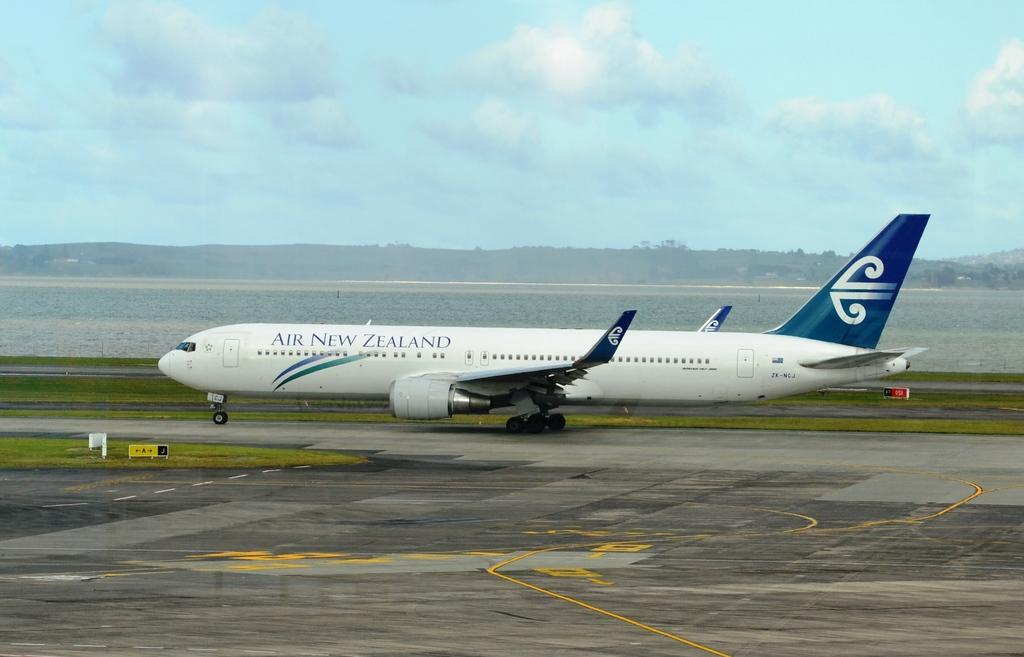What is the airplane doing in the image? The airplane is taking off from the land in the image. What company operates the airplane? The airplane has "AIR NEW ZEALAND" written on it, indicating that it is operated by Air New Zealand. What can be seen in the background of the image? There is sky and mountains visible in the background of the image. What type of crack is visible on the airplane's wing in the image? There is no crack visible on the airplane's wing in the image. What machine is responsible for generating hope in the image? There is no machine or reference to hope present in the image; it simply shows an airplane taking off. 